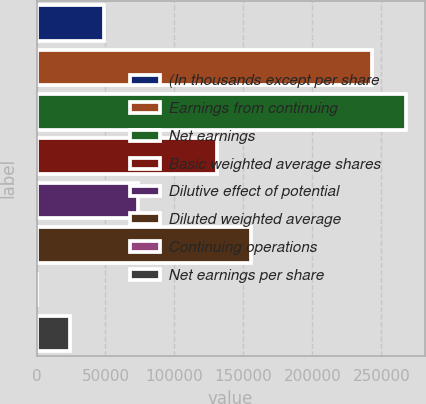<chart> <loc_0><loc_0><loc_500><loc_500><bar_chart><fcel>(In thousands except per share<fcel>Earnings from continuing<fcel>Net earnings<fcel>Basic weighted average shares<fcel>Dilutive effect of potential<fcel>Diluted weighted average<fcel>Continuing operations<fcel>Net earnings per share<nl><fcel>49019.7<fcel>243562<fcel>268071<fcel>130964<fcel>73528.6<fcel>155473<fcel>1.86<fcel>24510.8<nl></chart> 